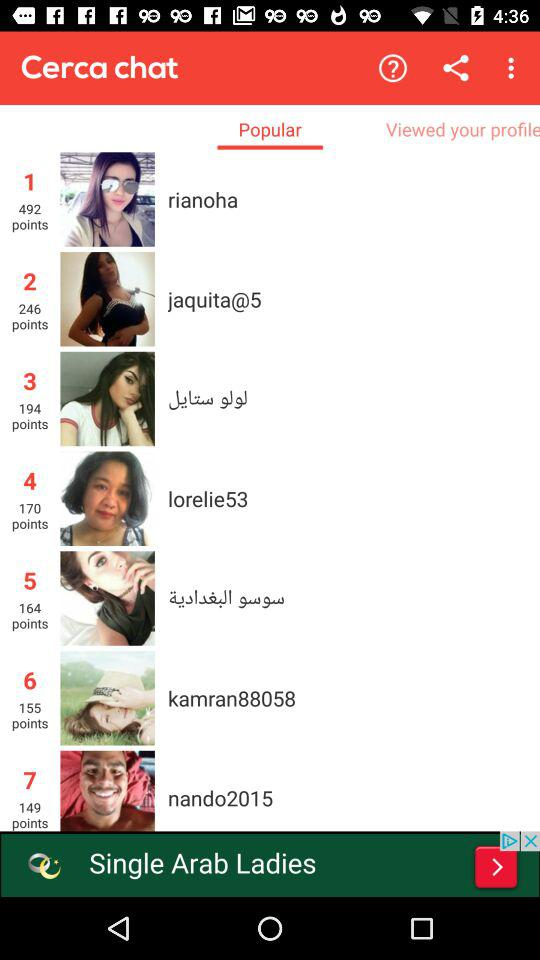What is the app name? The app name is "Cerca chat". 